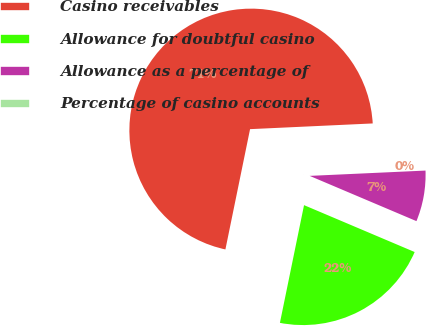Convert chart. <chart><loc_0><loc_0><loc_500><loc_500><pie_chart><fcel>Casino receivables<fcel>Allowance for doubtful casino<fcel>Allowance as a percentage of<fcel>Percentage of casino accounts<nl><fcel>71.05%<fcel>21.84%<fcel>7.11%<fcel>0.01%<nl></chart> 